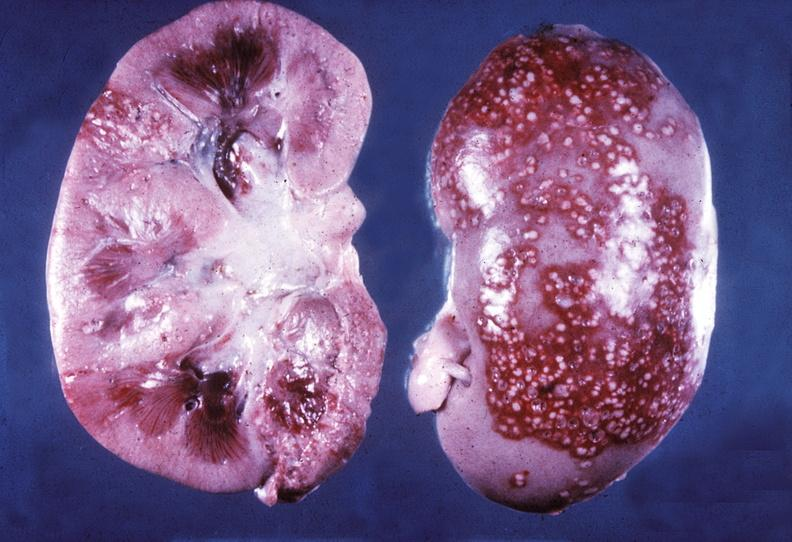where is this?
Answer the question using a single word or phrase. Urinary 